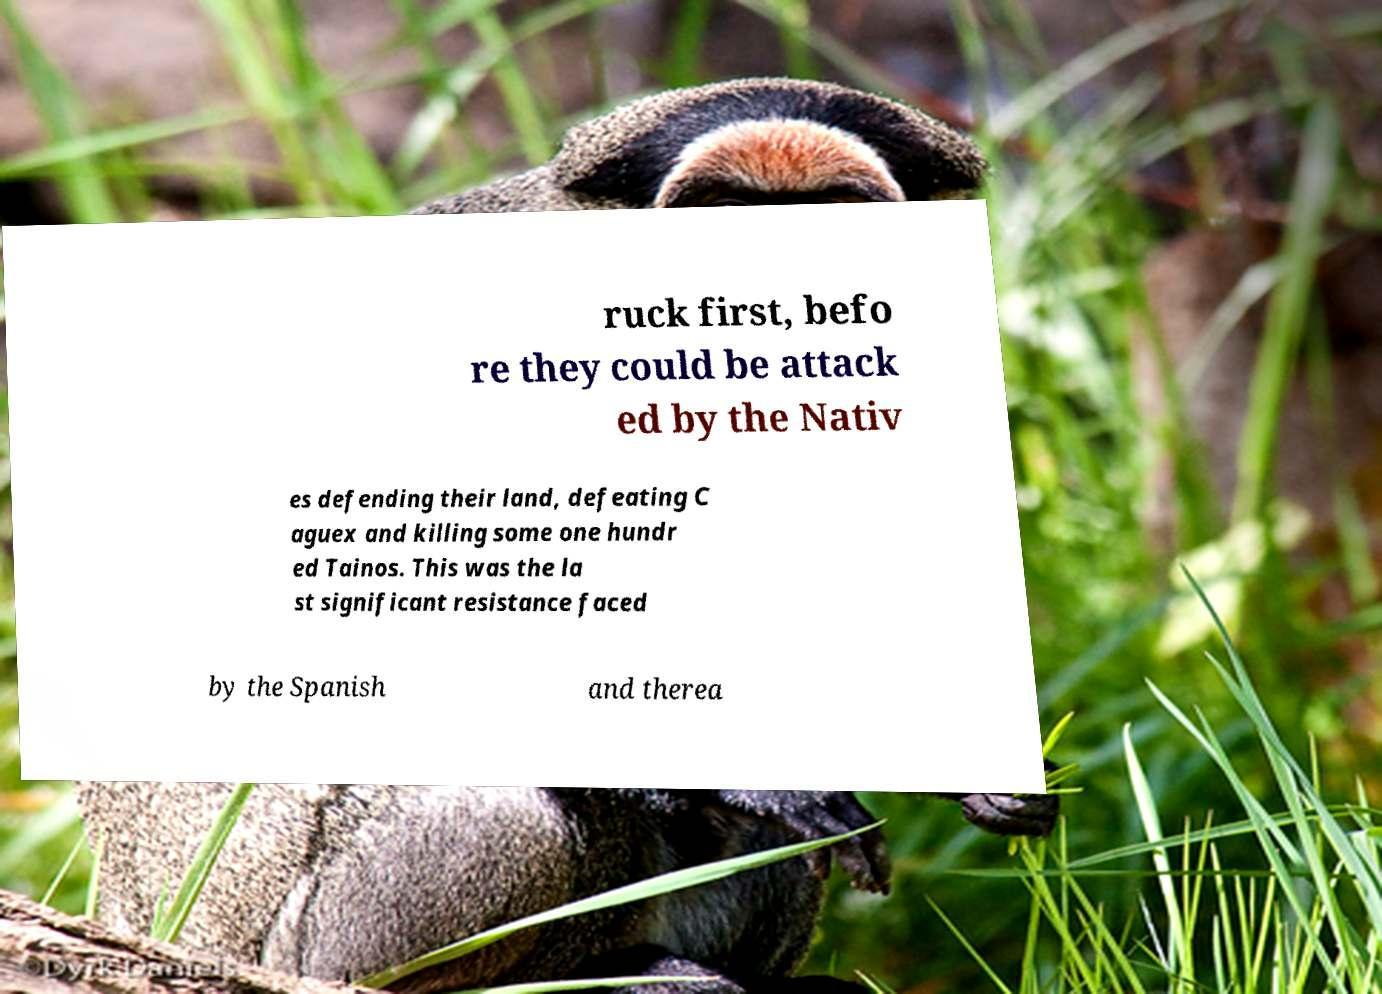Please read and relay the text visible in this image. What does it say? ruck first, befo re they could be attack ed by the Nativ es defending their land, defeating C aguex and killing some one hundr ed Tainos. This was the la st significant resistance faced by the Spanish and therea 